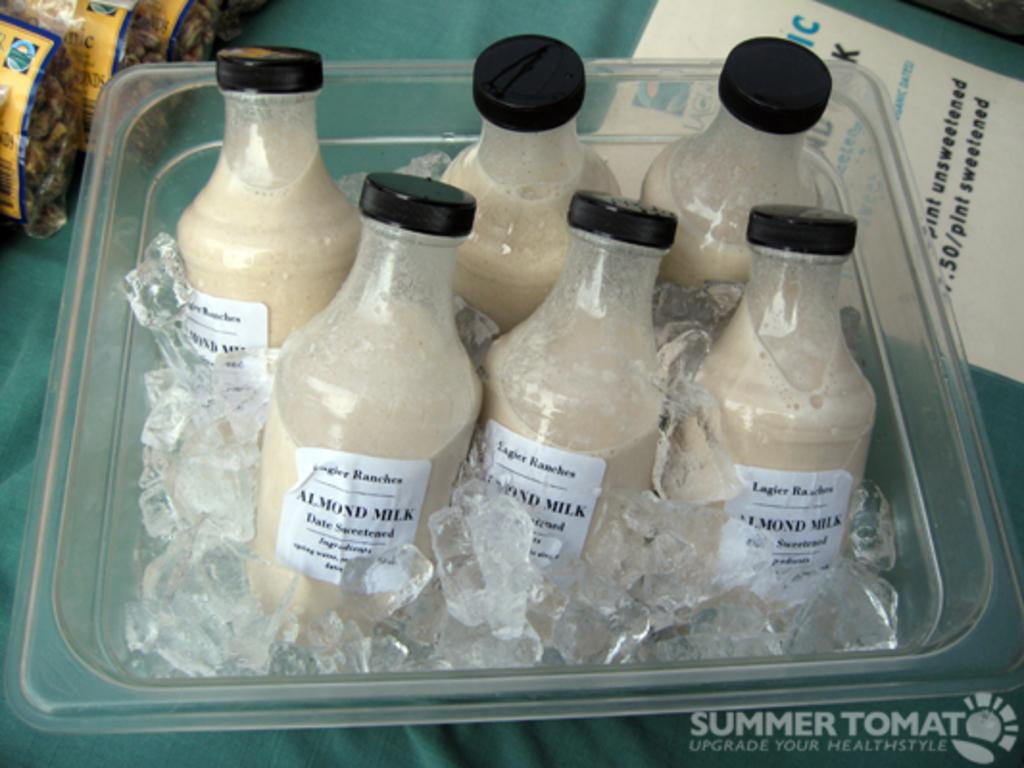<image>
Offer a succinct explanation of the picture presented. A clear container filled with ice and six bottles of Almond Milk inside. 